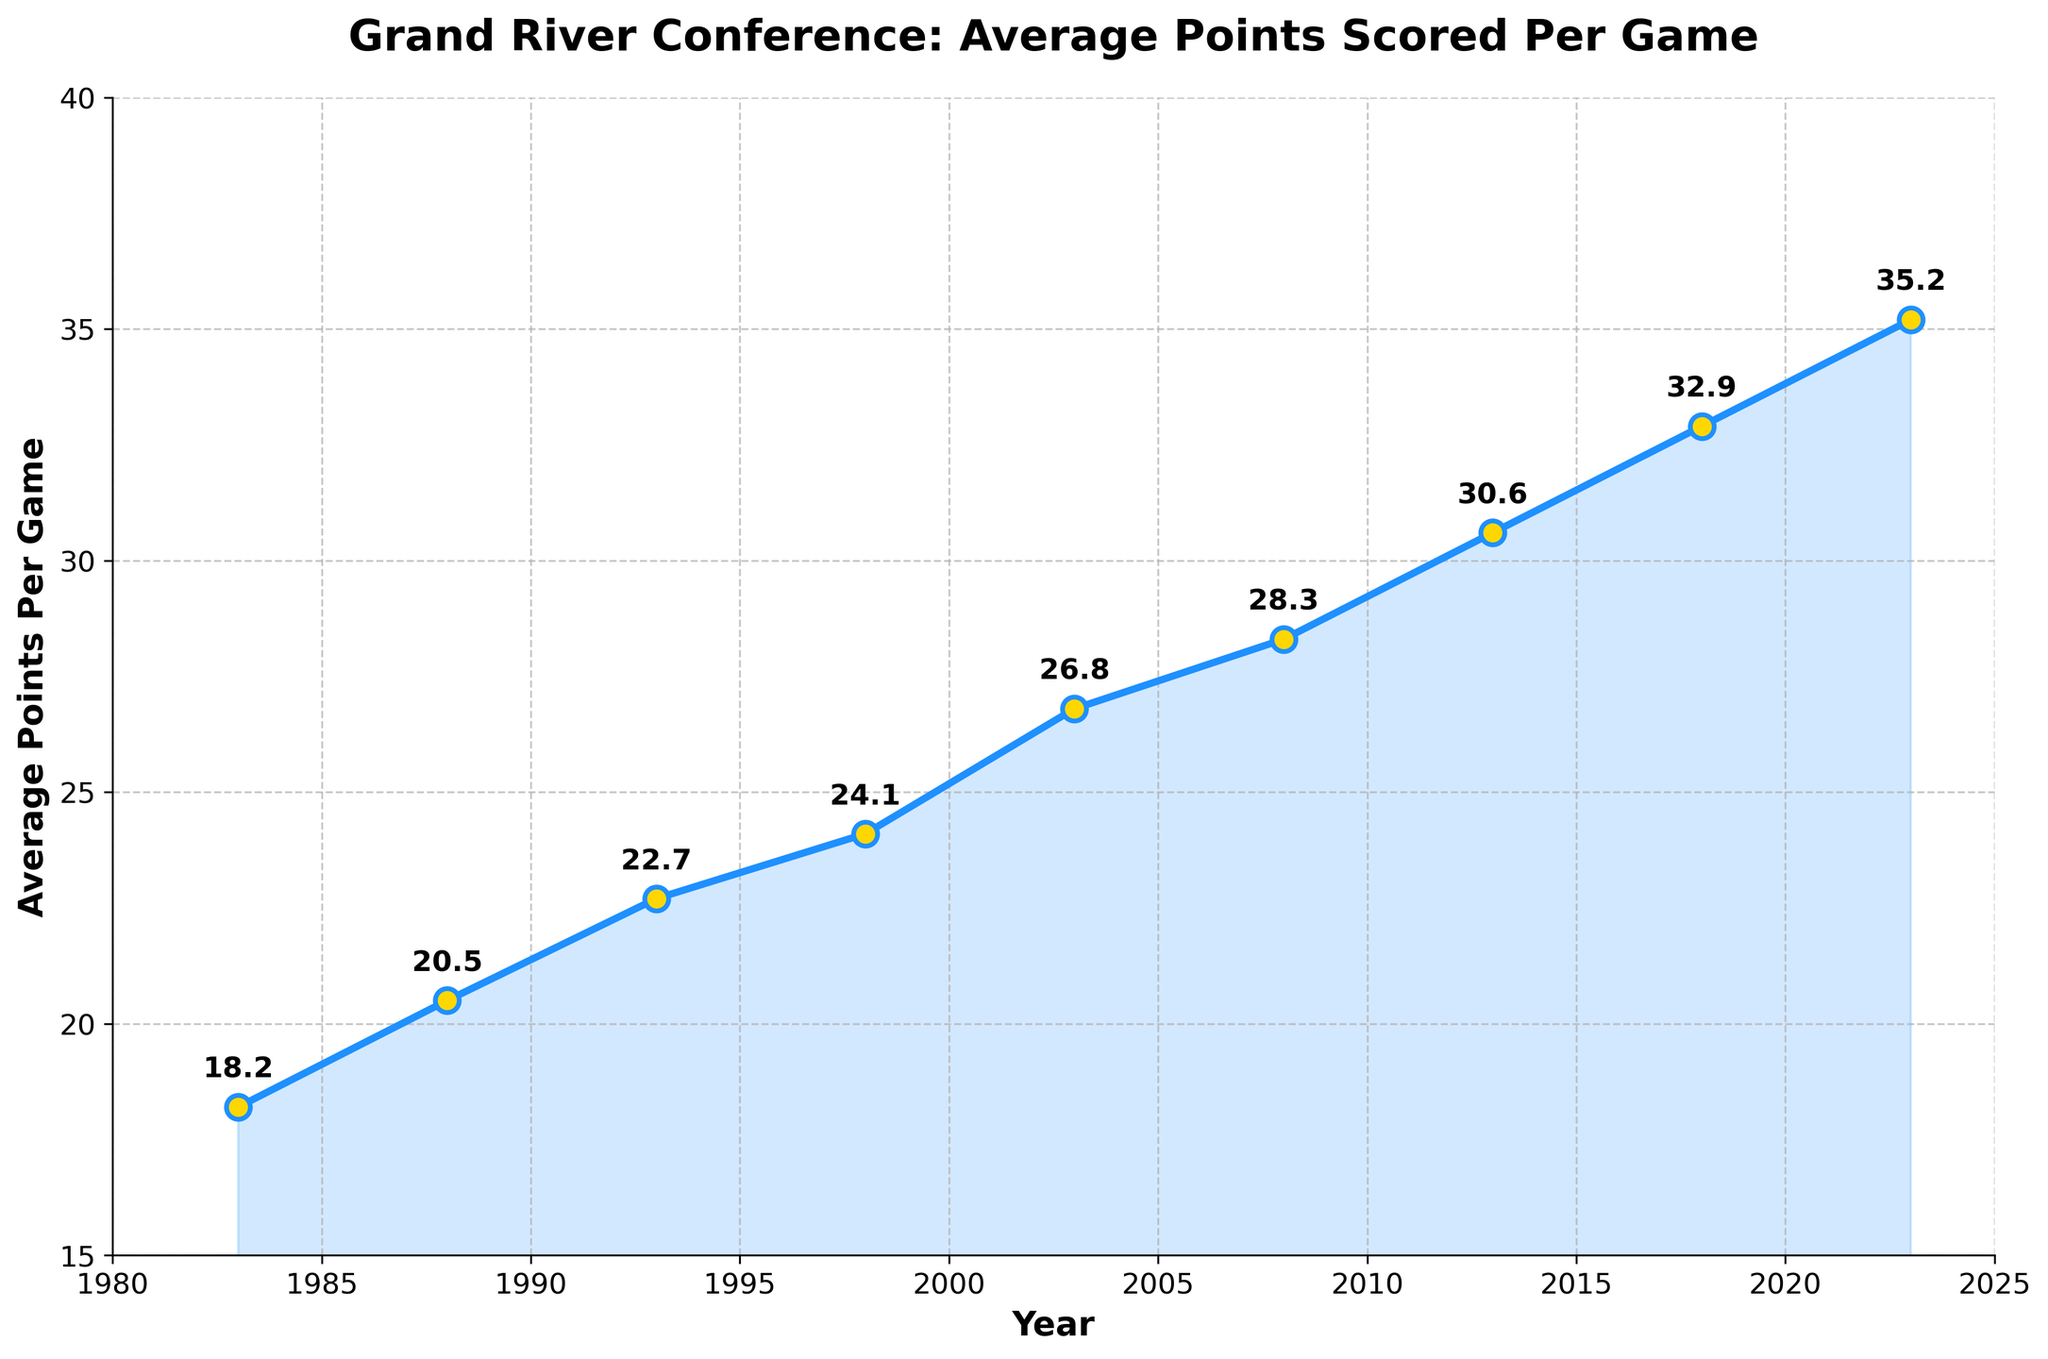What is the average points per game in the year 2008? The figure shows the average points scored each year, and for 2008, it is represented by a point at around 28.3.
Answer: 28.3 How much did the average points per game increase from 1983 to 2023? The figure shows that the average points in 1983 were 18.2 and in 2023 were 35.2. The increase is computed by subtracting the value for 1983 from the value for 2023. Therefore, 35.2 - 18.2 = 17.
Answer: 17 During which year was the average points per game approximately 22.7? By looking at the plotted points, the average points per game was around 22.7 in the year 1993.
Answer: 1993 Which five-year period shows the highest increase in average points per game? By comparing the increments between each pair of years shown in the figure: 1983-1988, 1988-1993, 1993-1998, 1998-2003, 2003-2008, 2008-2013, 2013-2018, and 2018-2023, the period 2013-2018 shows the highest increase: (32.9 - 30.6) = 2.3 points.
Answer: 2013-2018 How does the average points per game in 2003 compare to that in 1988? The figure indicates that the average points per game in 2003 (26.8) is higher than in 1988 (20.5).
Answer: 2003 is higher than 1988 What is the difference in average points per game between 1998 and 2013? From the figure, the difference is calculated by subtracting the value for 1998 (24.1) from the value for 2013 (30.6). Therefore, 30.6 - 24.1 = 6.5.
Answer: 6.5 What is the highest average points per game recorded and in which year did it occur? The figure shows the highest average points as 35.2 in the year 2023.
Answer: 35.2 in 2023 In which year did the average points per game first exceed 25 points? Examining the figure, the year when the average first exceeded 25 points was 2003 with 26.8 points.
Answer: 2003 